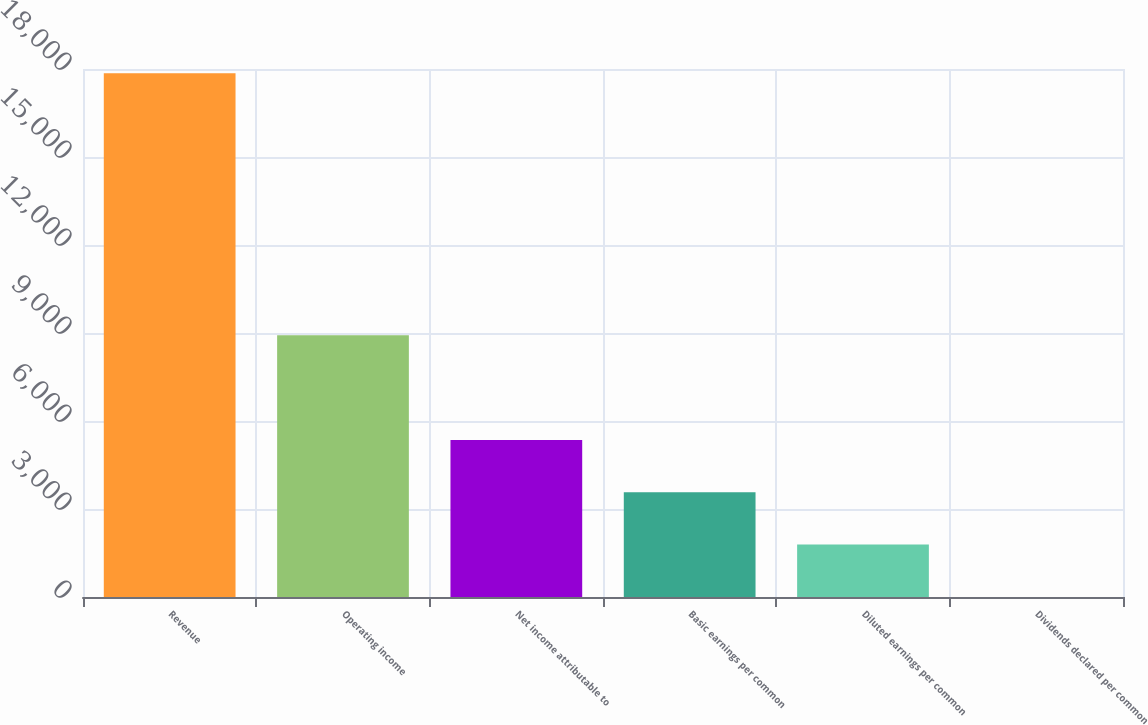<chart> <loc_0><loc_0><loc_500><loc_500><bar_chart><fcel>Revenue<fcel>Operating income<fcel>Net income attributable to<fcel>Basic earnings per common<fcel>Diluted earnings per common<fcel>Dividends declared per common<nl><fcel>17853<fcel>8926.64<fcel>5356.09<fcel>3570.81<fcel>1785.53<fcel>0.25<nl></chart> 